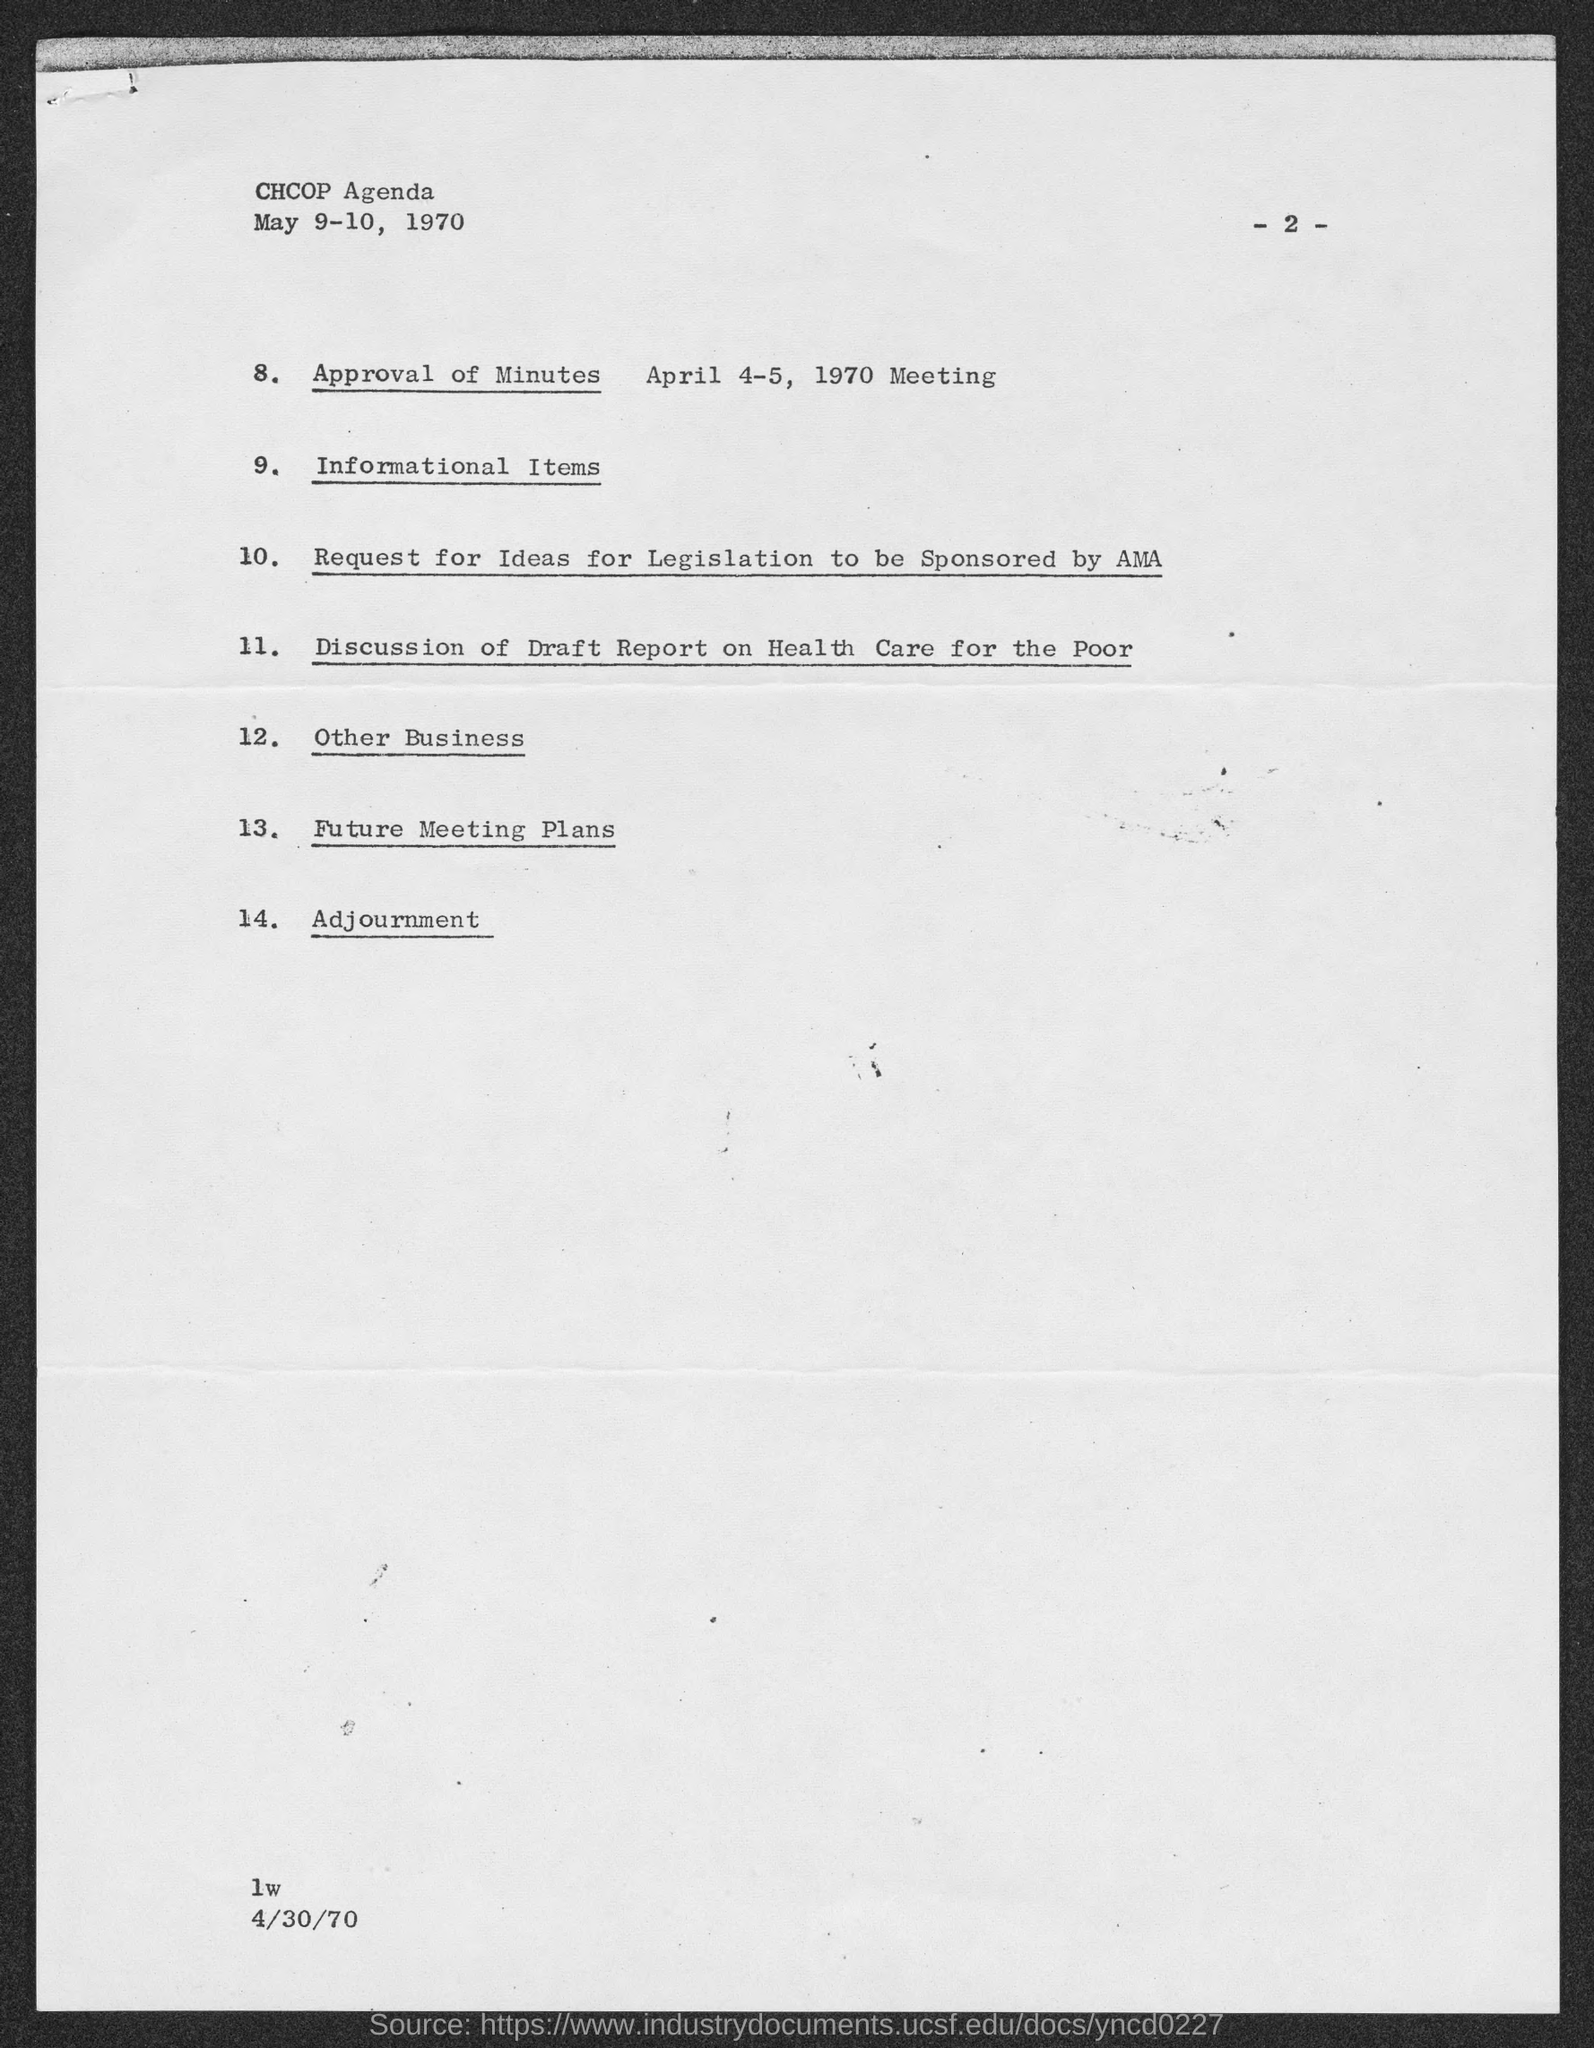What is the page no mentioned in this document?
Keep it short and to the point. -2-. What agenda is given in the header of the document?
Your response must be concise. CHCOP Agenda. 